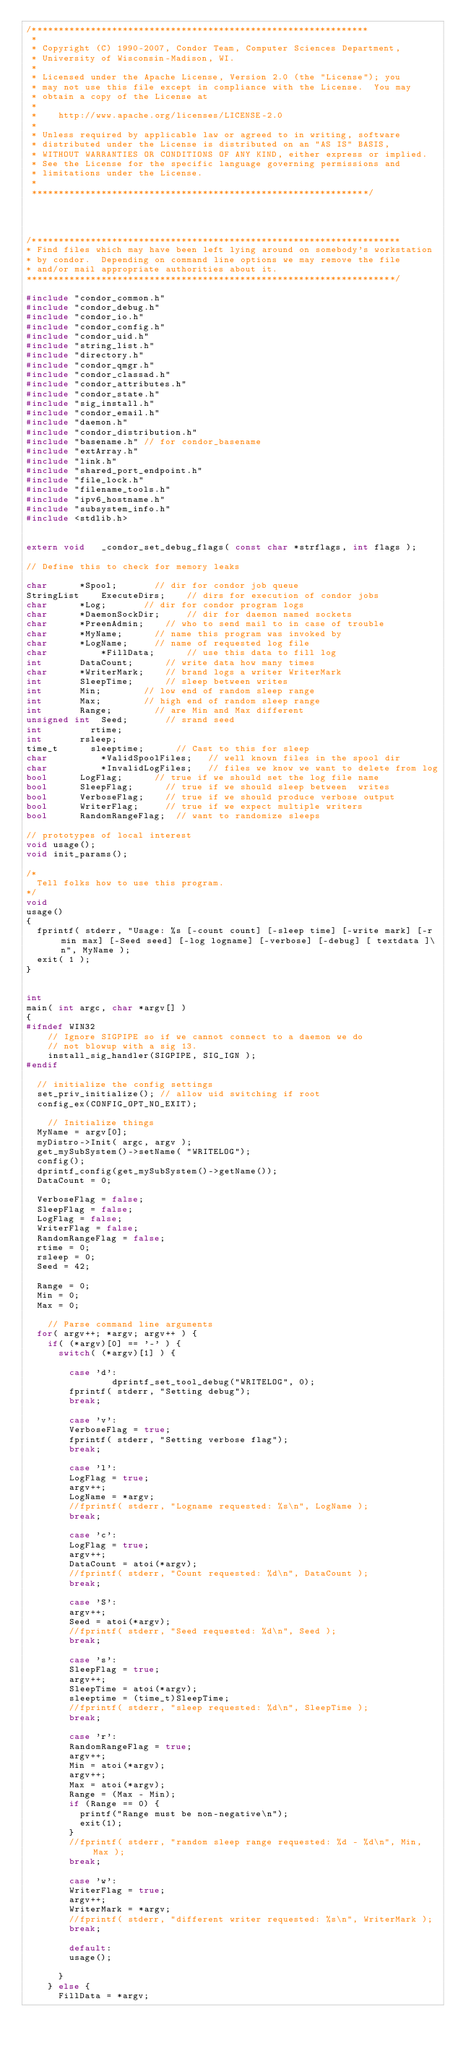Convert code to text. <code><loc_0><loc_0><loc_500><loc_500><_C++_>/***************************************************************
 *
 * Copyright (C) 1990-2007, Condor Team, Computer Sciences Department,
 * University of Wisconsin-Madison, WI.
 * 
 * Licensed under the Apache License, Version 2.0 (the "License"); you
 * may not use this file except in compliance with the License.  You may
 * obtain a copy of the License at
 * 
 *    http://www.apache.org/licenses/LICENSE-2.0
 * 
 * Unless required by applicable law or agreed to in writing, software
 * distributed under the License is distributed on an "AS IS" BASIS,
 * WITHOUT WARRANTIES OR CONDITIONS OF ANY KIND, either express or implied.
 * See the License for the specific language governing permissions and
 * limitations under the License.
 *
 ***************************************************************/


 

/*********************************************************************
* Find files which may have been left lying around on somebody's workstation
* by condor.  Depending on command line options we may remove the file
* and/or mail appropriate authorities about it.
*********************************************************************/

#include "condor_common.h"
#include "condor_debug.h"
#include "condor_io.h"
#include "condor_config.h"
#include "condor_uid.h"
#include "string_list.h"
#include "directory.h"
#include "condor_qmgr.h"
#include "condor_classad.h"
#include "condor_attributes.h"
#include "condor_state.h"
#include "sig_install.h"
#include "condor_email.h"
#include "daemon.h"
#include "condor_distribution.h"
#include "basename.h" // for condor_basename 
#include "extArray.h"
#include "link.h"
#include "shared_port_endpoint.h"
#include "file_lock.h"
#include "filename_tools.h"
#include "ipv6_hostname.h"
#include "subsystem_info.h"
#include <stdlib.h>


extern void		_condor_set_debug_flags( const char *strflags, int flags );

// Define this to check for memory leaks

char			*Spool;				// dir for condor job queue
StringList   	ExecuteDirs;		// dirs for execution of condor jobs
char			*Log;				// dir for condor program logs
char			*DaemonSockDir;     // dir for daemon named sockets
char			*PreenAdmin;		// who to send mail to in case of trouble
char			*MyName;			// name this program was invoked by
char			*LogName;			// name of requested log file
char        	*FillData;			// use this data to fill log
int				DataCount;			// write data how many times
char 			*WriterMark;		// brand logs a writer WriterMark
int				SleepTime;			// sleep between writes
int 			Min;				// low end of random sleep range
int				Max;				// high end of random sleep range
int 			Range;				// are Min and Max different
unsigned int 	Seed;				// srand seed
int    			rtime;
int				rsleep;
time_t 			sleeptime;			// Cast to this for sleep
char        	*ValidSpoolFiles;   // well known files in the spool dir
char        	*InvalidLogFiles;   // files we know we want to delete from log
bool			LogFlag;			// true if we should set the log file name
bool			SleepFlag;			// true if we should sleep between  writes
bool			VerboseFlag;		// true if we should produce verbose output
bool			WriterFlag;			// true if we expect multiple writers
bool			RandomRangeFlag;	// want to randomize sleeps

// prototypes of local interest
void usage();
void init_params();

/*
  Tell folks how to use this program.
*/
void
usage()
{
	fprintf( stderr, "Usage: %s [-count count] [-sleep time] [-write mark] [-r min max] [-Seed seed] [-log logname] [-verbose] [-debug] [ textdata ]\n", MyName );
	exit( 1 );
}


int
main( int argc, char *argv[] )
{
#ifndef WIN32
		// Ignore SIGPIPE so if we cannot connect to a daemon we do
		// not blowup with a sig 13.
    install_sig_handler(SIGPIPE, SIG_IGN );
#endif

	// initialize the config settings
	set_priv_initialize(); // allow uid switching if root
	config_ex(CONFIG_OPT_NO_EXIT);
	
		// Initialize things
	MyName = argv[0];
	myDistro->Init( argc, argv );
	get_mySubSystem()->setName( "WRITELOG");
	config();
	dprintf_config(get_mySubSystem()->getName());
	DataCount = 0;

	VerboseFlag = false;
	SleepFlag = false;
	LogFlag = false;
	WriterFlag = false;
	RandomRangeFlag = false;
	rtime = 0;
	rsleep = 0;
	Seed = 42;

	Range = 0;
	Min = 0;
	Max = 0;

		// Parse command line arguments
	for( argv++; *argv; argv++ ) {
		if( (*argv)[0] == '-' ) {
			switch( (*argv)[1] ) {
			
			  case 'd':
                dprintf_set_tool_debug("WRITELOG", 0);
				fprintf( stderr, "Setting debug");
				break;

			  case 'v':
				VerboseFlag = true;
				fprintf( stderr, "Setting verbose flag");
				break;

			  case 'l':
				LogFlag = true;
				argv++;
				LogName = *argv;
				//fprintf( stderr, "Logname requested: %s\n", LogName );
				break;

			  case 'c':
				LogFlag = true;
				argv++;
				DataCount = atoi(*argv);
				//fprintf( stderr, "Count requested: %d\n", DataCount );
				break;

			  case 'S':
				argv++;
				Seed = atoi(*argv);
				//fprintf( stderr, "Seed requested: %d\n", Seed );
				break;

			  case 's':
				SleepFlag = true;
				argv++;
				SleepTime = atoi(*argv);
				sleeptime = (time_t)SleepTime;
				//fprintf( stderr, "sleep requested: %d\n", SleepTime );
				break;

			  case 'r':
				RandomRangeFlag = true;
				argv++;
				Min = atoi(*argv);
				argv++;
				Max = atoi(*argv);
				Range = (Max - Min);
				if (Range == 0) {
					printf("Range must be non-negative\n");
					exit(1);
				}
				//fprintf( stderr, "random sleep range requested: %d - %d\n", Min, Max );
				break;

			  case 'w':
				WriterFlag = true;
				argv++;
				WriterMark = *argv;
				//fprintf( stderr, "different writer requested: %s\n", WriterMark );
				break;

			  default:
				usage();

			}
		} else {
			FillData = *argv;</code> 